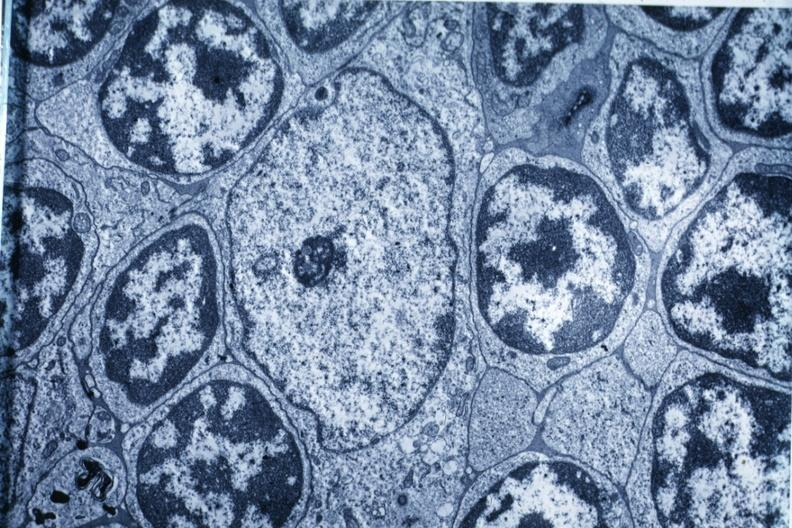s thymus present?
Answer the question using a single word or phrase. Yes 